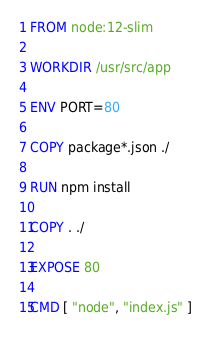<code> <loc_0><loc_0><loc_500><loc_500><_Dockerfile_>FROM node:12-slim

WORKDIR /usr/src/app

ENV PORT=80

COPY package*.json ./

RUN npm install

COPY . ./

EXPOSE 80

CMD [ "node", "index.js" ]</code> 